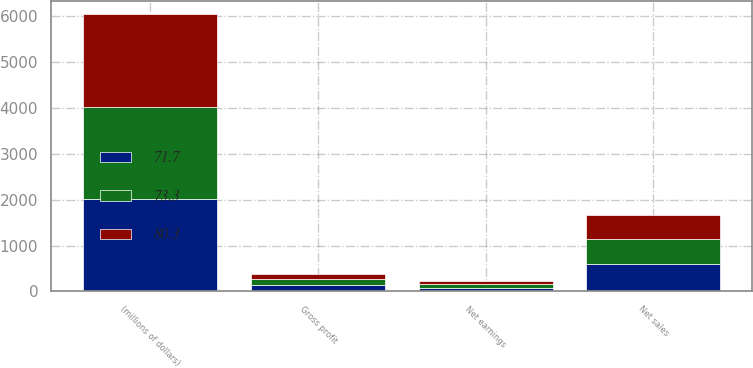<chart> <loc_0><loc_0><loc_500><loc_500><stacked_bar_chart><ecel><fcel>(millions of dollars)<fcel>Net sales<fcel>Gross profit<fcel>Net earnings<nl><fcel>71.7<fcel>2016<fcel>601.8<fcel>134.1<fcel>71.7<nl><fcel>80.3<fcel>2015<fcel>519<fcel>118.6<fcel>73.3<nl><fcel>73.3<fcel>2014<fcel>546.4<fcel>124.5<fcel>80.3<nl></chart> 